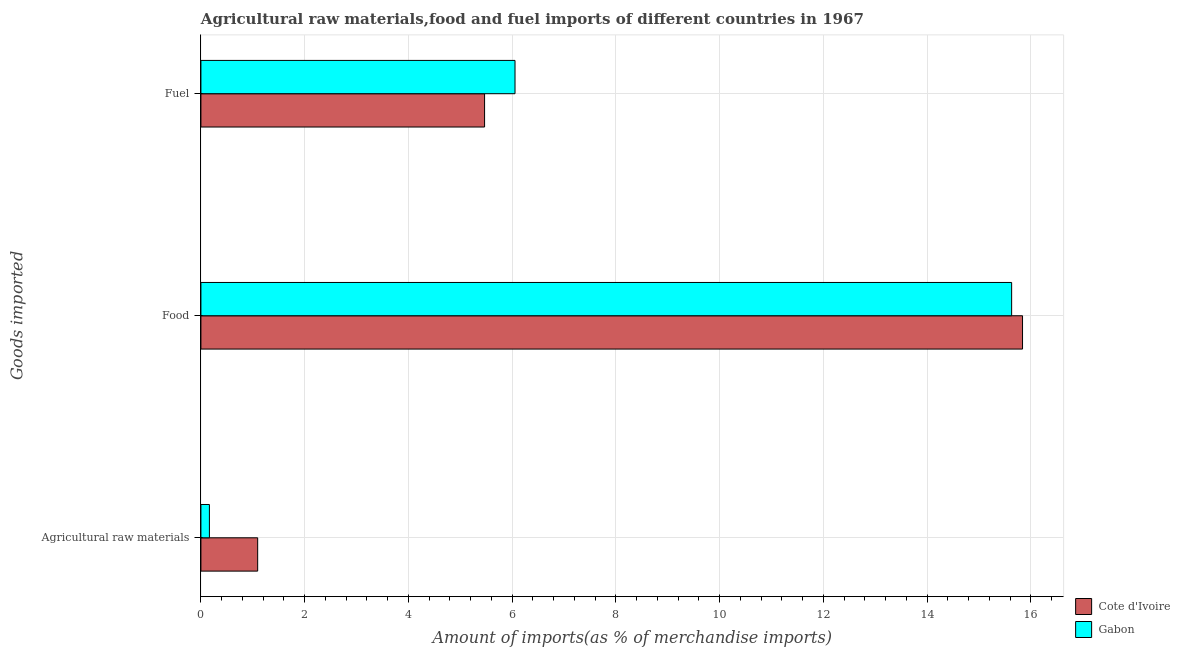How many bars are there on the 2nd tick from the bottom?
Provide a short and direct response. 2. What is the label of the 2nd group of bars from the top?
Give a very brief answer. Food. What is the percentage of raw materials imports in Cote d'Ivoire?
Offer a very short reply. 1.09. Across all countries, what is the maximum percentage of food imports?
Offer a very short reply. 15.84. Across all countries, what is the minimum percentage of fuel imports?
Your response must be concise. 5.47. In which country was the percentage of fuel imports maximum?
Your answer should be very brief. Gabon. In which country was the percentage of fuel imports minimum?
Give a very brief answer. Cote d'Ivoire. What is the total percentage of raw materials imports in the graph?
Keep it short and to the point. 1.26. What is the difference between the percentage of raw materials imports in Gabon and that in Cote d'Ivoire?
Your answer should be compact. -0.93. What is the difference between the percentage of food imports in Gabon and the percentage of fuel imports in Cote d'Ivoire?
Your answer should be compact. 10.16. What is the average percentage of fuel imports per country?
Offer a terse response. 5.76. What is the difference between the percentage of food imports and percentage of fuel imports in Cote d'Ivoire?
Offer a very short reply. 10.37. In how many countries, is the percentage of fuel imports greater than 14.4 %?
Ensure brevity in your answer.  0. What is the ratio of the percentage of raw materials imports in Cote d'Ivoire to that in Gabon?
Offer a very short reply. 6.68. What is the difference between the highest and the second highest percentage of food imports?
Your answer should be compact. 0.21. What is the difference between the highest and the lowest percentage of fuel imports?
Your answer should be compact. 0.59. Is the sum of the percentage of raw materials imports in Gabon and Cote d'Ivoire greater than the maximum percentage of fuel imports across all countries?
Offer a very short reply. No. What does the 2nd bar from the top in Food represents?
Give a very brief answer. Cote d'Ivoire. What does the 2nd bar from the bottom in Fuel represents?
Give a very brief answer. Gabon. How many bars are there?
Your answer should be compact. 6. Are all the bars in the graph horizontal?
Offer a terse response. Yes. How many countries are there in the graph?
Give a very brief answer. 2. Does the graph contain any zero values?
Your answer should be very brief. No. Does the graph contain grids?
Offer a terse response. Yes. How are the legend labels stacked?
Offer a terse response. Vertical. What is the title of the graph?
Make the answer very short. Agricultural raw materials,food and fuel imports of different countries in 1967. What is the label or title of the X-axis?
Ensure brevity in your answer.  Amount of imports(as % of merchandise imports). What is the label or title of the Y-axis?
Give a very brief answer. Goods imported. What is the Amount of imports(as % of merchandise imports) in Cote d'Ivoire in Agricultural raw materials?
Provide a succinct answer. 1.09. What is the Amount of imports(as % of merchandise imports) of Gabon in Agricultural raw materials?
Ensure brevity in your answer.  0.16. What is the Amount of imports(as % of merchandise imports) in Cote d'Ivoire in Food?
Provide a short and direct response. 15.84. What is the Amount of imports(as % of merchandise imports) of Gabon in Food?
Offer a terse response. 15.63. What is the Amount of imports(as % of merchandise imports) of Cote d'Ivoire in Fuel?
Offer a very short reply. 5.47. What is the Amount of imports(as % of merchandise imports) of Gabon in Fuel?
Give a very brief answer. 6.05. Across all Goods imported, what is the maximum Amount of imports(as % of merchandise imports) in Cote d'Ivoire?
Your answer should be compact. 15.84. Across all Goods imported, what is the maximum Amount of imports(as % of merchandise imports) of Gabon?
Ensure brevity in your answer.  15.63. Across all Goods imported, what is the minimum Amount of imports(as % of merchandise imports) in Cote d'Ivoire?
Your answer should be compact. 1.09. Across all Goods imported, what is the minimum Amount of imports(as % of merchandise imports) in Gabon?
Keep it short and to the point. 0.16. What is the total Amount of imports(as % of merchandise imports) in Cote d'Ivoire in the graph?
Your answer should be compact. 22.4. What is the total Amount of imports(as % of merchandise imports) of Gabon in the graph?
Offer a terse response. 21.85. What is the difference between the Amount of imports(as % of merchandise imports) of Cote d'Ivoire in Agricultural raw materials and that in Food?
Make the answer very short. -14.74. What is the difference between the Amount of imports(as % of merchandise imports) in Gabon in Agricultural raw materials and that in Food?
Your answer should be compact. -15.46. What is the difference between the Amount of imports(as % of merchandise imports) of Cote d'Ivoire in Agricultural raw materials and that in Fuel?
Provide a short and direct response. -4.37. What is the difference between the Amount of imports(as % of merchandise imports) in Gabon in Agricultural raw materials and that in Fuel?
Offer a terse response. -5.89. What is the difference between the Amount of imports(as % of merchandise imports) in Cote d'Ivoire in Food and that in Fuel?
Offer a very short reply. 10.37. What is the difference between the Amount of imports(as % of merchandise imports) of Gabon in Food and that in Fuel?
Ensure brevity in your answer.  9.57. What is the difference between the Amount of imports(as % of merchandise imports) of Cote d'Ivoire in Agricultural raw materials and the Amount of imports(as % of merchandise imports) of Gabon in Food?
Offer a terse response. -14.53. What is the difference between the Amount of imports(as % of merchandise imports) of Cote d'Ivoire in Agricultural raw materials and the Amount of imports(as % of merchandise imports) of Gabon in Fuel?
Your response must be concise. -4.96. What is the difference between the Amount of imports(as % of merchandise imports) of Cote d'Ivoire in Food and the Amount of imports(as % of merchandise imports) of Gabon in Fuel?
Your response must be concise. 9.78. What is the average Amount of imports(as % of merchandise imports) of Cote d'Ivoire per Goods imported?
Ensure brevity in your answer.  7.47. What is the average Amount of imports(as % of merchandise imports) of Gabon per Goods imported?
Offer a very short reply. 7.28. What is the difference between the Amount of imports(as % of merchandise imports) of Cote d'Ivoire and Amount of imports(as % of merchandise imports) of Gabon in Agricultural raw materials?
Provide a succinct answer. 0.93. What is the difference between the Amount of imports(as % of merchandise imports) of Cote d'Ivoire and Amount of imports(as % of merchandise imports) of Gabon in Food?
Your answer should be very brief. 0.21. What is the difference between the Amount of imports(as % of merchandise imports) of Cote d'Ivoire and Amount of imports(as % of merchandise imports) of Gabon in Fuel?
Your answer should be very brief. -0.59. What is the ratio of the Amount of imports(as % of merchandise imports) of Cote d'Ivoire in Agricultural raw materials to that in Food?
Provide a short and direct response. 0.07. What is the ratio of the Amount of imports(as % of merchandise imports) of Gabon in Agricultural raw materials to that in Food?
Your answer should be compact. 0.01. What is the ratio of the Amount of imports(as % of merchandise imports) of Cote d'Ivoire in Agricultural raw materials to that in Fuel?
Offer a terse response. 0.2. What is the ratio of the Amount of imports(as % of merchandise imports) of Gabon in Agricultural raw materials to that in Fuel?
Offer a terse response. 0.03. What is the ratio of the Amount of imports(as % of merchandise imports) in Cote d'Ivoire in Food to that in Fuel?
Your answer should be compact. 2.9. What is the ratio of the Amount of imports(as % of merchandise imports) in Gabon in Food to that in Fuel?
Keep it short and to the point. 2.58. What is the difference between the highest and the second highest Amount of imports(as % of merchandise imports) of Cote d'Ivoire?
Your answer should be compact. 10.37. What is the difference between the highest and the second highest Amount of imports(as % of merchandise imports) of Gabon?
Your answer should be compact. 9.57. What is the difference between the highest and the lowest Amount of imports(as % of merchandise imports) of Cote d'Ivoire?
Your response must be concise. 14.74. What is the difference between the highest and the lowest Amount of imports(as % of merchandise imports) of Gabon?
Offer a very short reply. 15.46. 